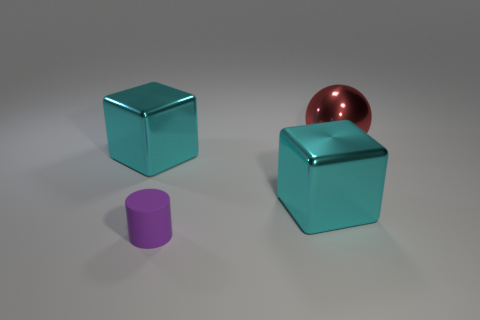Subtract 1 blocks. How many blocks are left? 1 Subtract all cylinders. How many objects are left? 3 Add 4 big spheres. How many big spheres exist? 5 Add 1 large spheres. How many objects exist? 5 Subtract 1 purple cylinders. How many objects are left? 3 Subtract all purple blocks. Subtract all red balls. How many blocks are left? 2 Subtract all blue blocks. How many green spheres are left? 0 Subtract all small blue shiny cylinders. Subtract all big cyan objects. How many objects are left? 2 Add 4 matte objects. How many matte objects are left? 5 